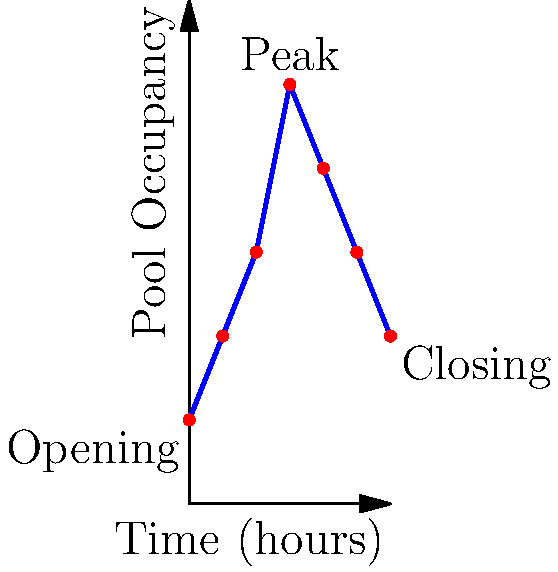Given the graph showing pool occupancy over time, estimate the average occupancy during the busiest 4-hour period. Assume the pool opens at 6 AM and closes at 6 PM. To solve this problem, we need to follow these steps:

1. Identify the busiest 4-hour period:
   Looking at the graph, we can see that the occupancy peaks around the 6-hour mark.
   The busiest 4-hour period appears to be from hour 4 to hour 8.

2. Estimate occupancy at key points:
   - At hour 4: approximately 15 people
   - At hour 6: peak of 25 people
   - At hour 8: approximately 20 people

3. Calculate the average:
   We'll use the occupancy at the start, middle, and end of this period.
   Average = $\frac{15 + 25 + 20}{3} = \frac{60}{3} = 20$

Therefore, the estimated average occupancy during the busiest 4-hour period is 20 people.
Answer: 20 people 